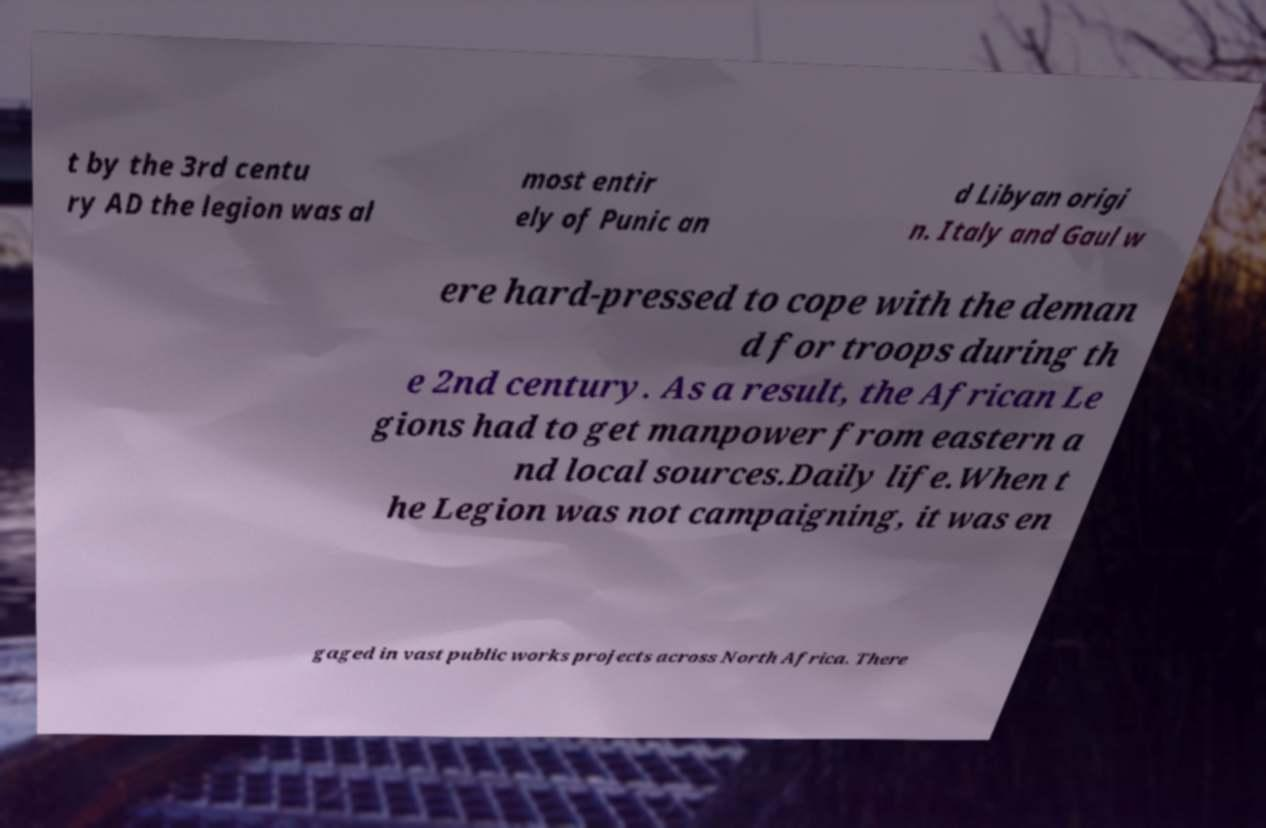Can you read and provide the text displayed in the image?This photo seems to have some interesting text. Can you extract and type it out for me? t by the 3rd centu ry AD the legion was al most entir ely of Punic an d Libyan origi n. Italy and Gaul w ere hard-pressed to cope with the deman d for troops during th e 2nd century. As a result, the African Le gions had to get manpower from eastern a nd local sources.Daily life.When t he Legion was not campaigning, it was en gaged in vast public works projects across North Africa. There 